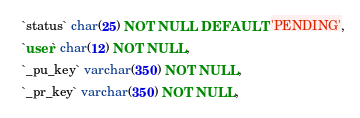<code> <loc_0><loc_0><loc_500><loc_500><_SQL_>  `status` char(25) NOT NULL DEFAULT 'PENDING',
  `user` char(12) NOT NULL,
  `_pu_key` varchar(350) NOT NULL,
  `_pr_key` varchar(350) NOT NULL,</code> 